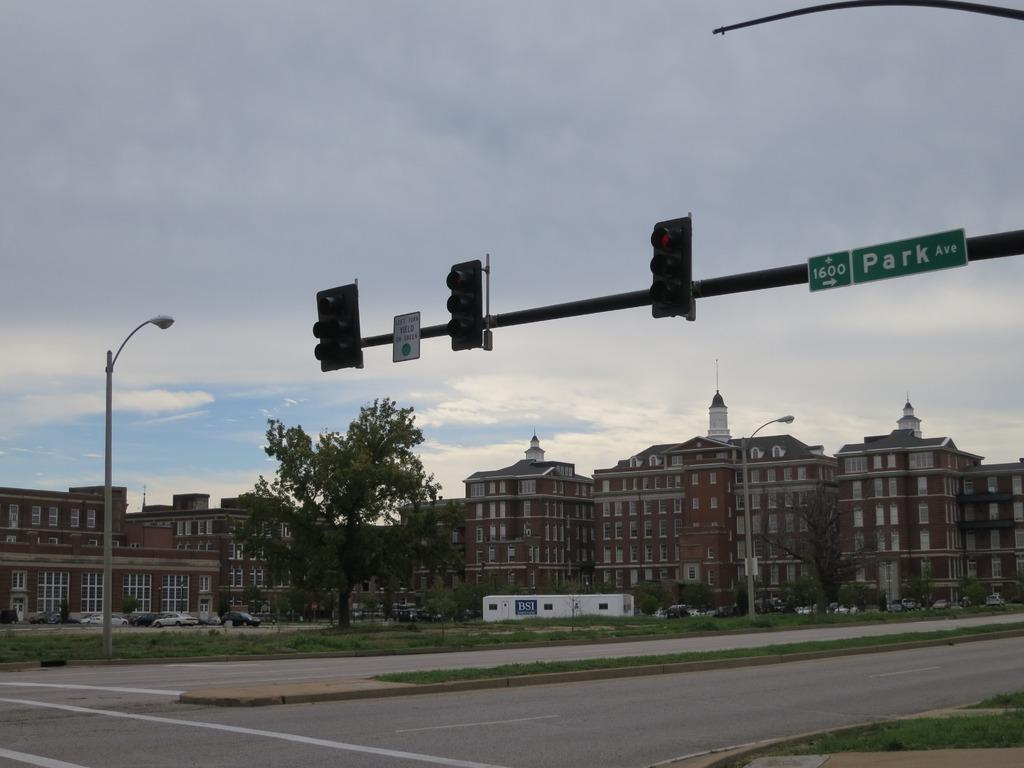<image>
Write a terse but informative summary of the picture. The intersection of 1600 Park Avenue has a lot of tall buildings nearby. 